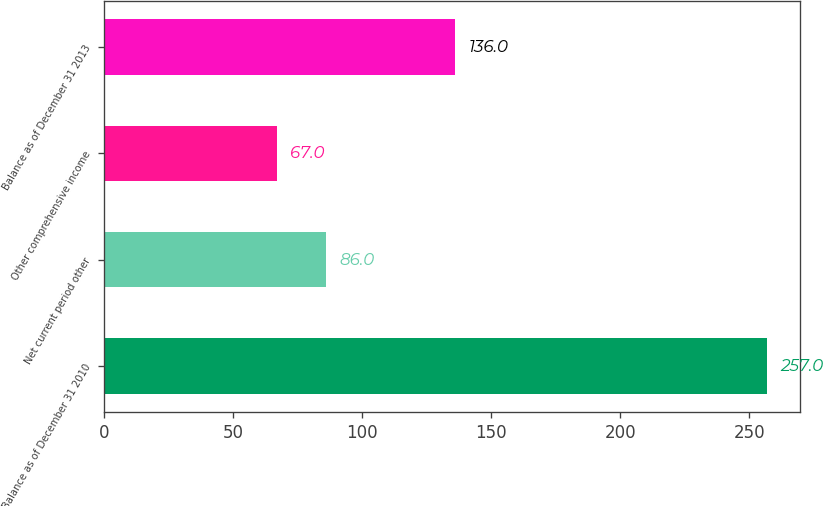<chart> <loc_0><loc_0><loc_500><loc_500><bar_chart><fcel>Balance as of December 31 2010<fcel>Net current period other<fcel>Other comprehensive income<fcel>Balance as of December 31 2013<nl><fcel>257<fcel>86<fcel>67<fcel>136<nl></chart> 